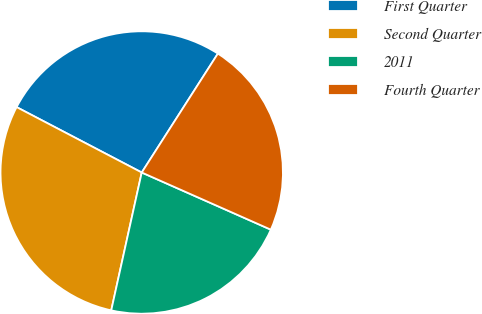<chart> <loc_0><loc_0><loc_500><loc_500><pie_chart><fcel>First Quarter<fcel>Second Quarter<fcel>2011<fcel>Fourth Quarter<nl><fcel>26.4%<fcel>29.2%<fcel>21.83%<fcel>22.57%<nl></chart> 